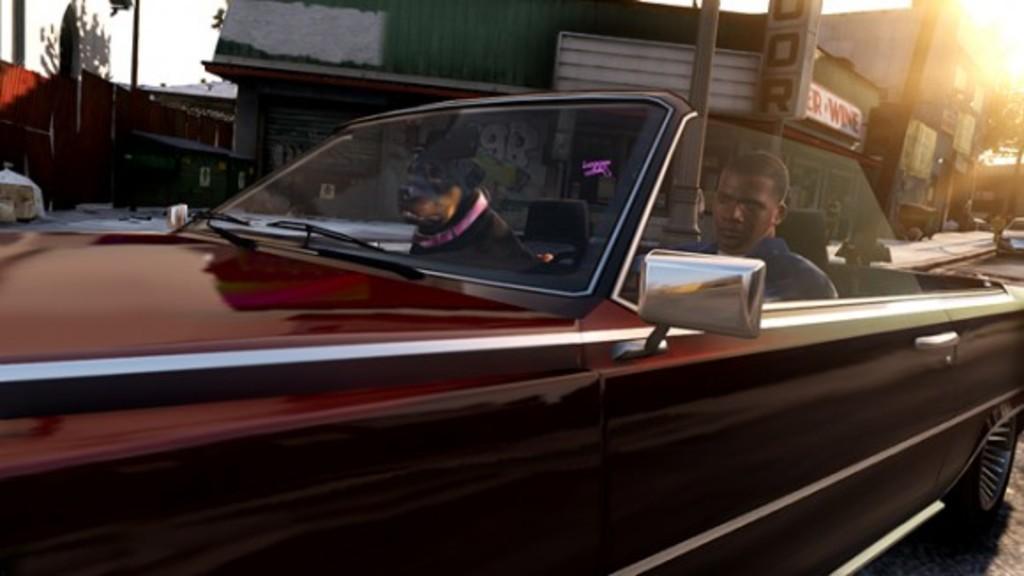In one or two sentences, can you explain what this image depicts? Here we can see a person and a dog sitting inside a car which is on the road. In the background we can see a building and trees. 